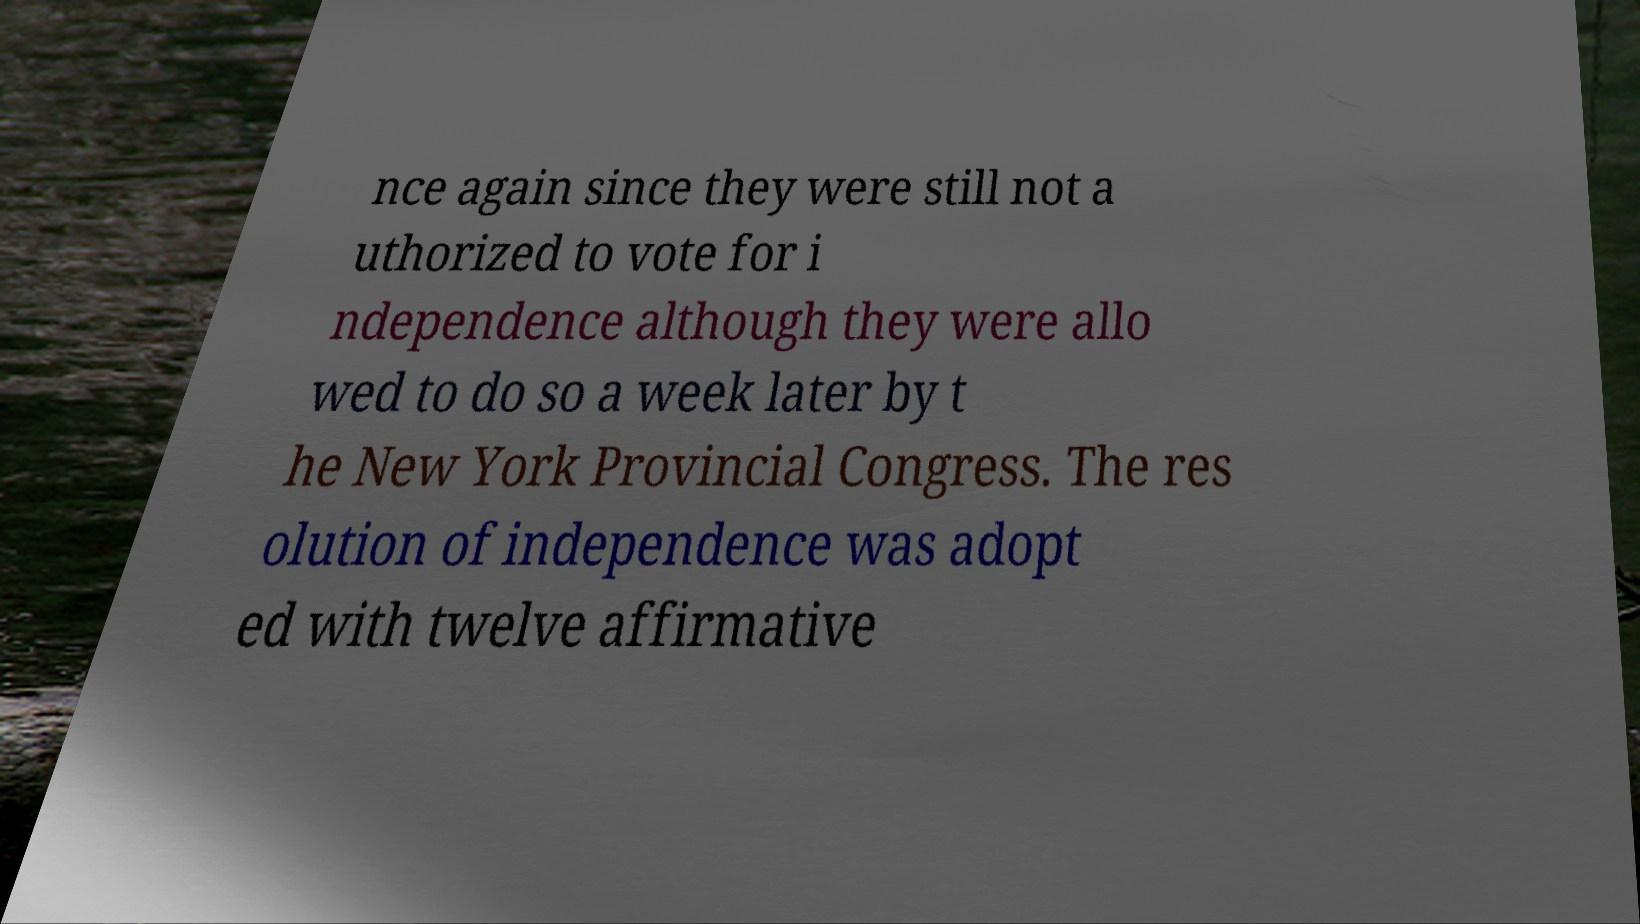Please identify and transcribe the text found in this image. nce again since they were still not a uthorized to vote for i ndependence although they were allo wed to do so a week later by t he New York Provincial Congress. The res olution of independence was adopt ed with twelve affirmative 